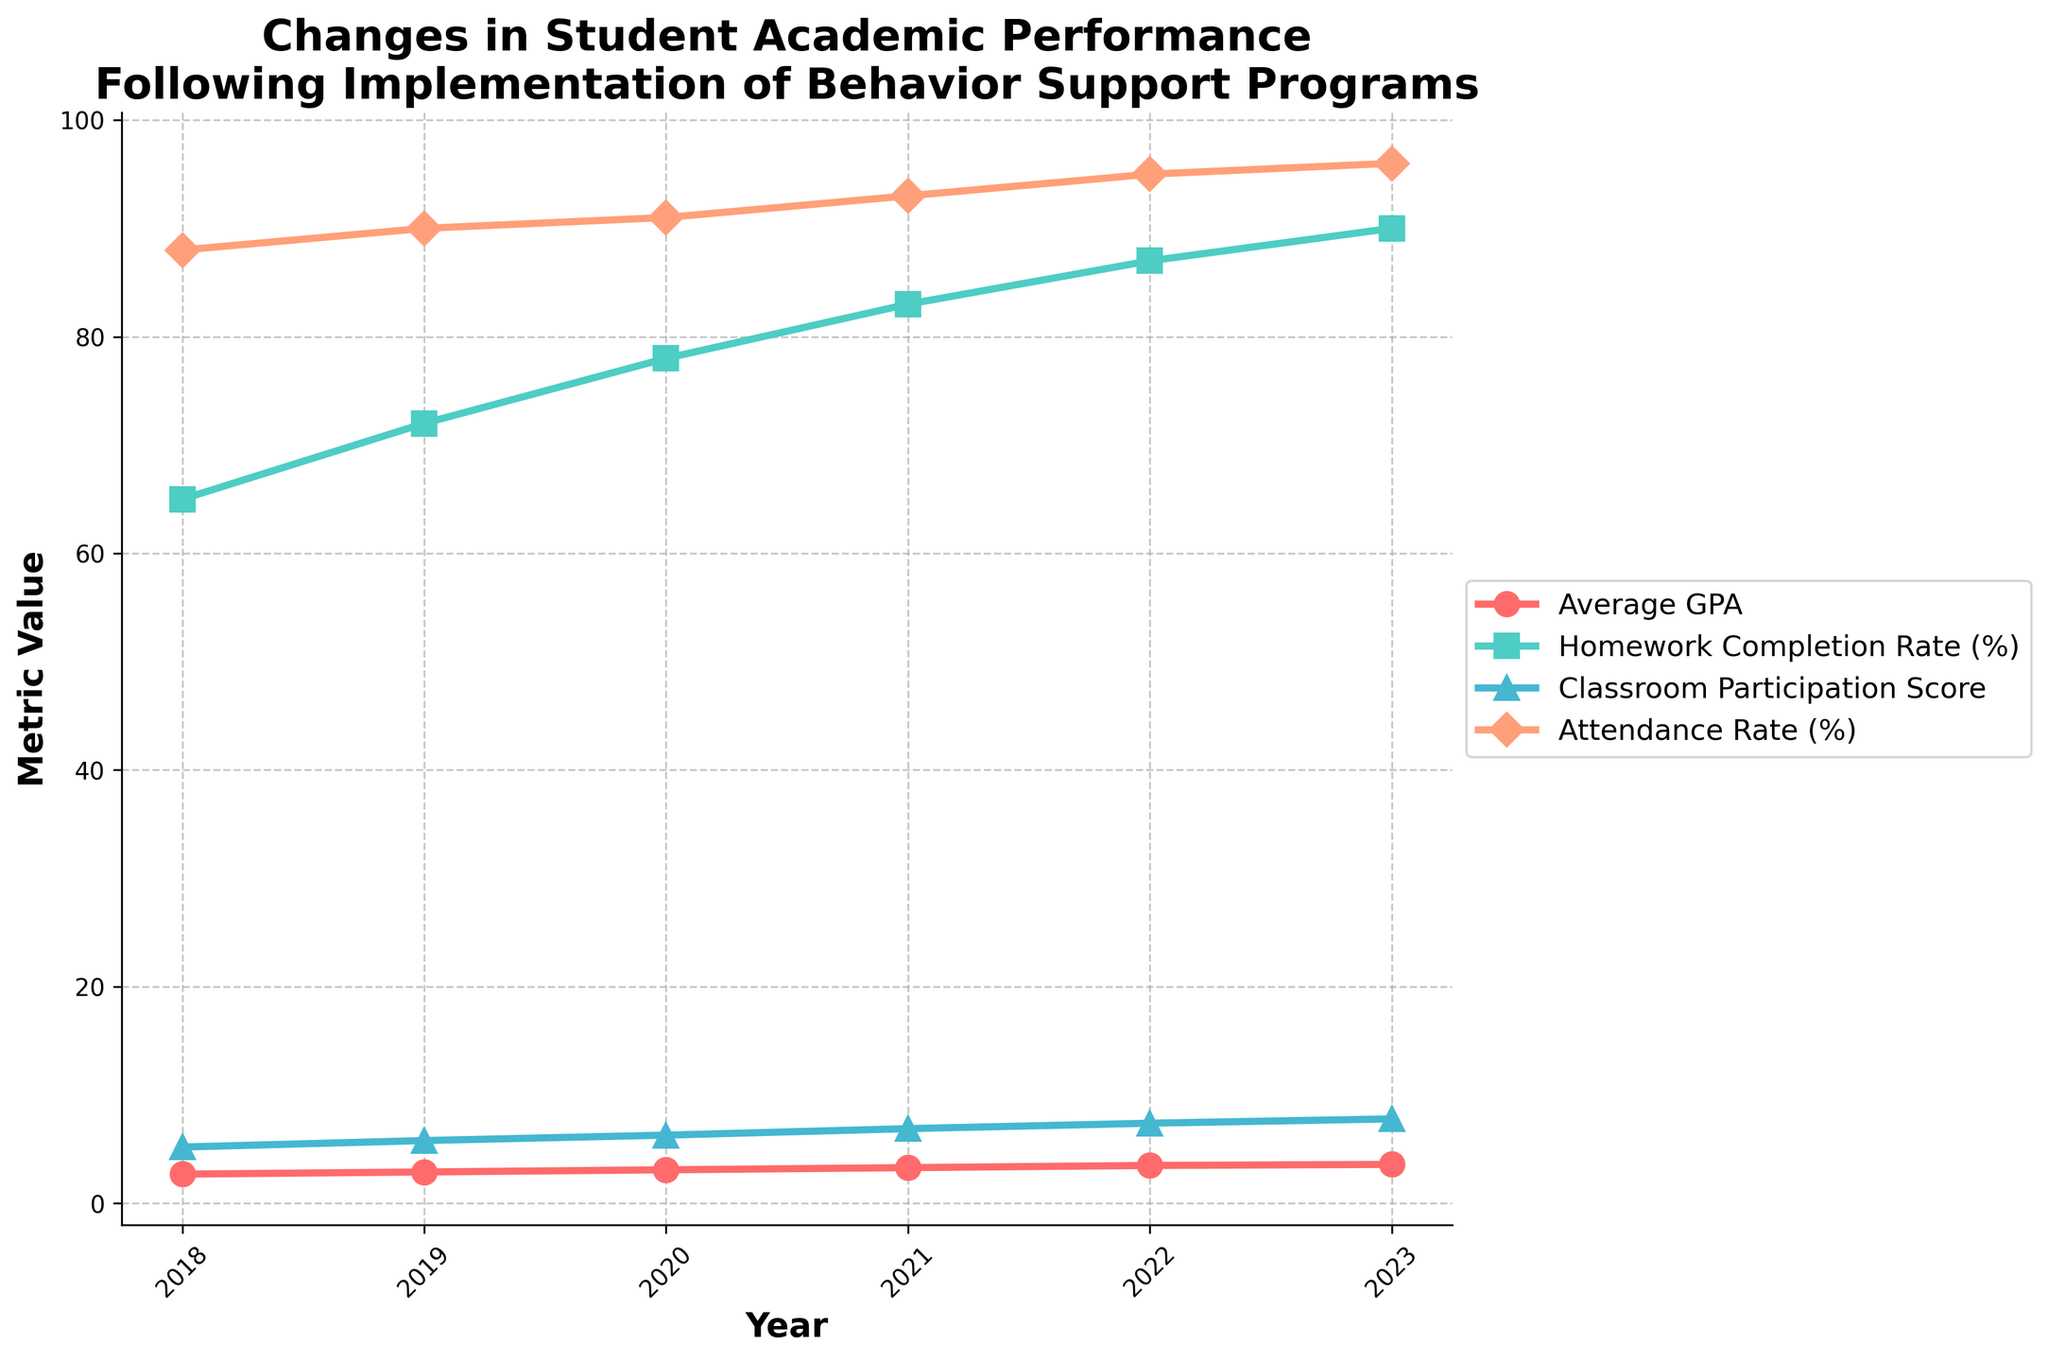What's the average GPA growth from 2018 to 2023? To find the average GPA growth, subtract the GPA of 2018 (2.7) from the GPA of 2023 (3.6), then divide by the number of years minus one. (3.6 - 2.7) / (2023 - 2018) = 0.18
Answer: 0.18 By how much did the homework completion rate (%) increase from 2018 to 2023? Subtract the homework completion rate of 2018 (65%) from that of 2023 (90%). 90% - 65% = 25%
Answer: 25% Which metric shows the most significant improvement over the period of 2018 to 2023? Compare the differences of metrics from 2018 to 2023: GPA (3.6 - 2.7 = 0.9), Homework Completion Rate (90% - 65% = 25%), Classroom Participation Score (7.8 - 5.2 = 2.6), and Attendance Rate (96% - 88% = 8%). The Homework Completion Rate increased the most by 25%.
Answer: Homework Completion Rate Which year shows the highest classroom participation score? Look at the line representing the Classroom Participation Score and identify the highest value on the y-axis. The highest value is 7.8 in 2023.
Answer: 2023 What is the overall trend in GPA from 2018 to 2023? Examine the line representing the Average GPA from 2018 to 2023. The GPA consistently increases each year, indicating a positive upward trend.
Answer: Increasing In what year did the attendance rate (%) cross 90%? Find the point where the attendance line crosses the 90% mark on the y-axis. This occurs between 2019 (90%) and 2020 (91%).
Answer: 2019 Compare the growth in Homework Completion Rate (%) and Attendance Rate (%) from 2018 to 2021. Which grew more? Calculate the growth for both metrics from 2018 to 2021: Homework Completion Rate grew from 65% to 83%, which is an 18% increase, while Attendance Rate grew from 88% to 93%, a 5% increase.
Answer: Homework Completion Rate What's the average Classroom Participation Score over the six years from 2018 to 2023? Sum the Classroom Participation Scores from 2018 to 2023 (5.2, 5.8, 6.3, 6.9, 7.4, 7.8) and divide by the number of years: (5.2 + 5.8 + 6.3 + 6.9 + 7.4 + 7.8) / 6 = 6.57
Answer: 6.57 Did the behavior support programs have a positive impact on Attendance Rate (%) over the years? Observe the trend of the Attendance Rate line from 2018 to 2023, which generally shows an upward movement from 88% to 96%, indicating improvement.
Answer: Yes What color represents the Homework Completion Rate (%) in the figure? Identify the color of the line and marker representing the Homework Completion Rate (%) according to the legend. It is represented by a green line and marker.
Answer: Green 